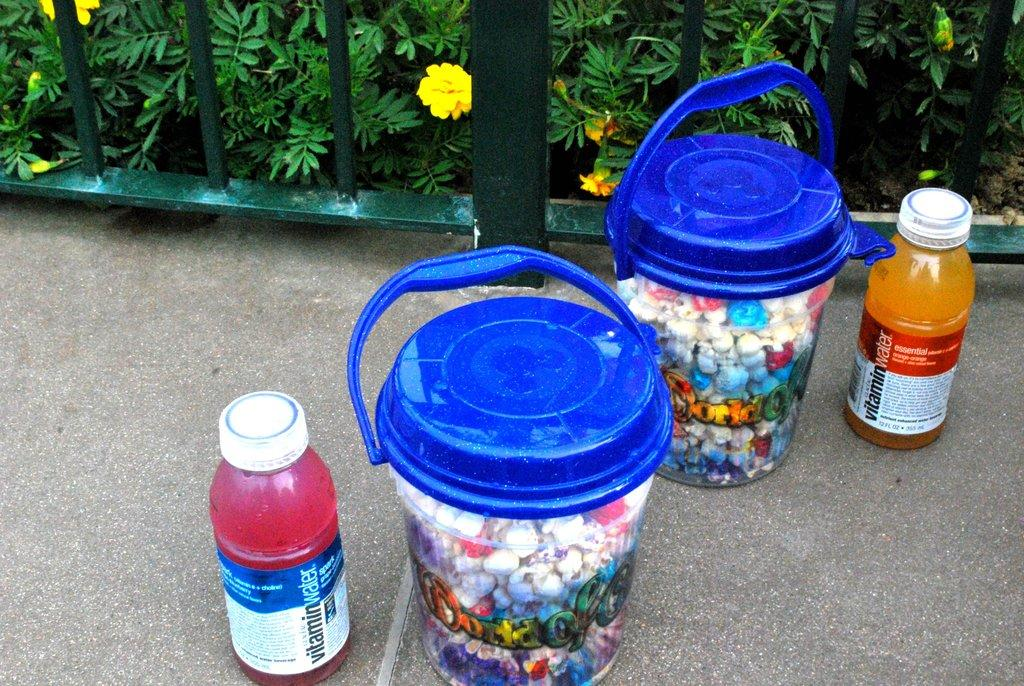<image>
Provide a brief description of the given image. Two bottles of vitamin water next to two buckets 